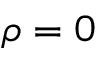<formula> <loc_0><loc_0><loc_500><loc_500>\rho = 0</formula> 